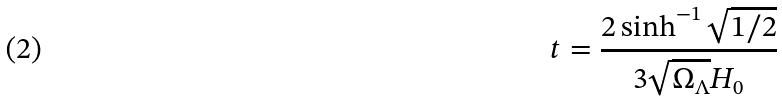Convert formula to latex. <formula><loc_0><loc_0><loc_500><loc_500>t = \frac { 2 \sinh ^ { - 1 } \sqrt { 1 / 2 } } { 3 \sqrt { \Omega _ { \Lambda } } H _ { 0 } }</formula> 